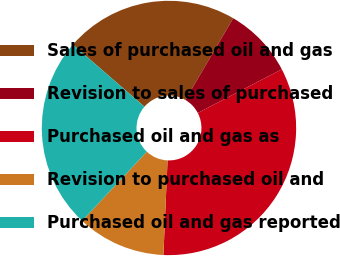<chart> <loc_0><loc_0><loc_500><loc_500><pie_chart><fcel>Sales of purchased oil and gas<fcel>Revision to sales of purchased<fcel>Purchased oil and gas as<fcel>Revision to purchased oil and<fcel>Purchased oil and gas reported<nl><fcel>22.06%<fcel>8.94%<fcel>33.33%<fcel>11.27%<fcel>24.4%<nl></chart> 